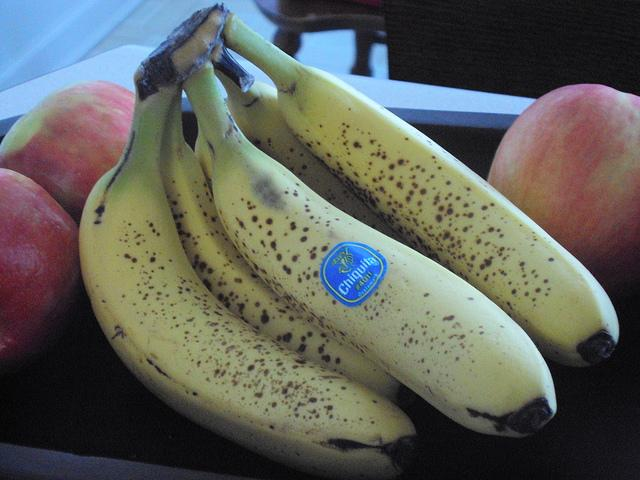Which fruit is too ripe?

Choices:
A) apple
B) plum
C) peach
D) banana banana 